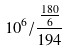<formula> <loc_0><loc_0><loc_500><loc_500>1 0 ^ { 6 } / \frac { \frac { 1 8 0 } { 6 } } { 1 9 4 }</formula> 